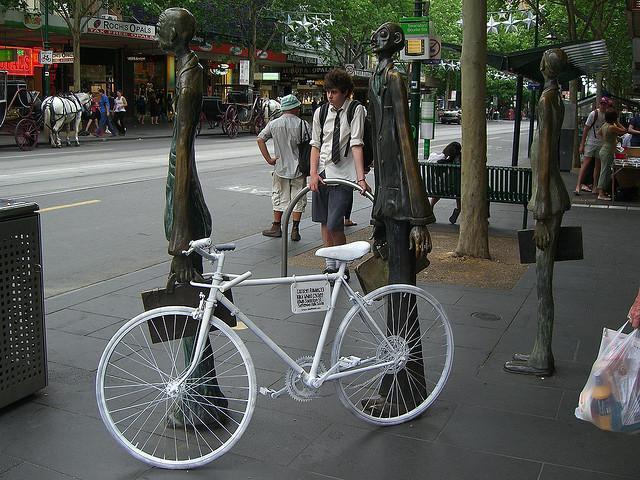How many statues of people are there?
Give a very brief answer. 3. How many people are there?
Give a very brief answer. 2. How many birds are in the air?
Give a very brief answer. 0. 